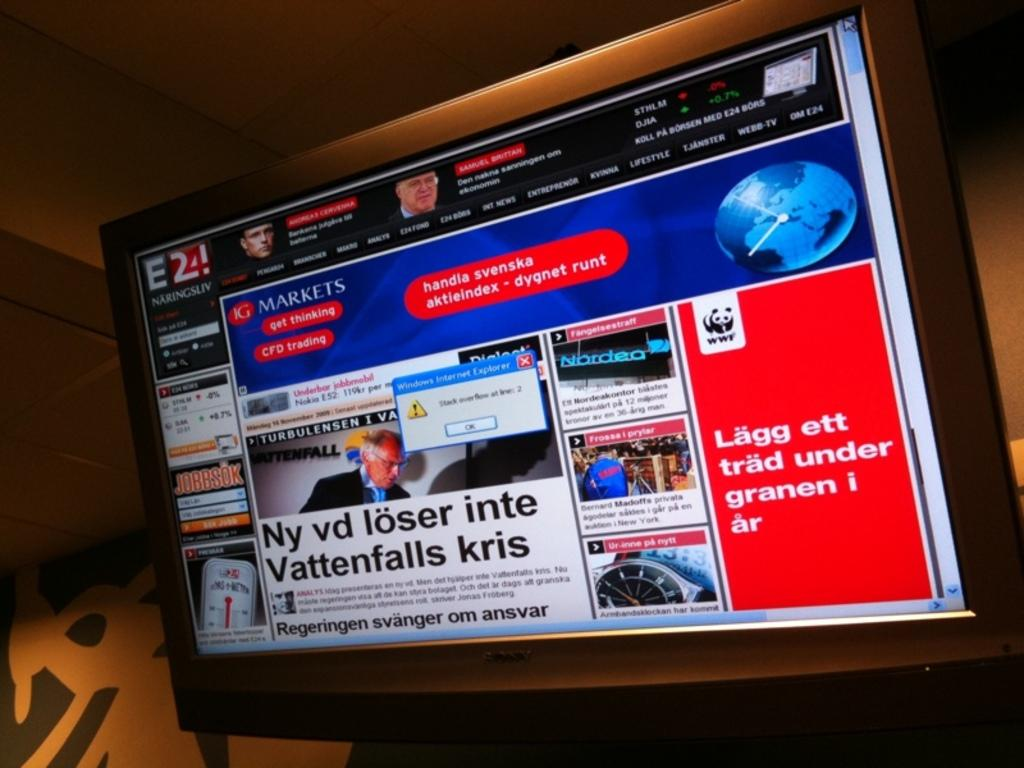What is displayed on the screen in the image? There is a screen with information in the image, and a popup alert message is visible on the screen. What can be seen in the background of the image? There is a wall in the background of the image. Are there any fairies flying around the screen in the image? No, there are no fairies present in the image. What side of the wall is visible in the image? The image only shows a wall in the background, and it does not provide information about which side is visible. 